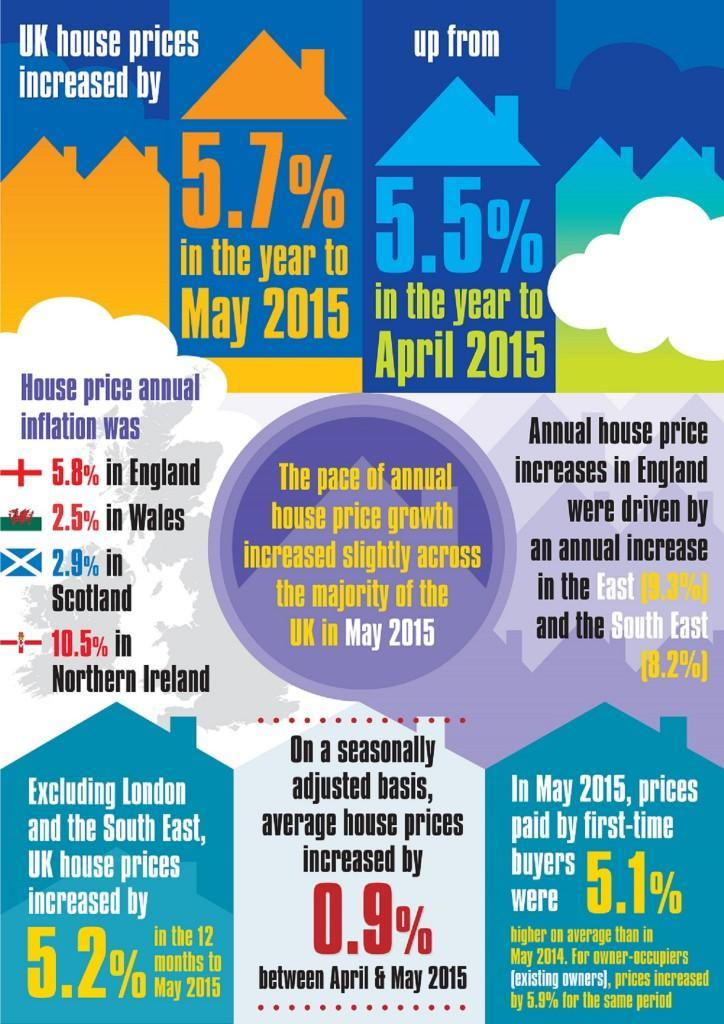House price annual inflation was highest in which country?
Answer the question with a short phrase. Northern Ireland House price annual inflation was lowest in which country? Wales How many countries flags are in this infographic? 4 How many months are mentioned in this infographic? 2 